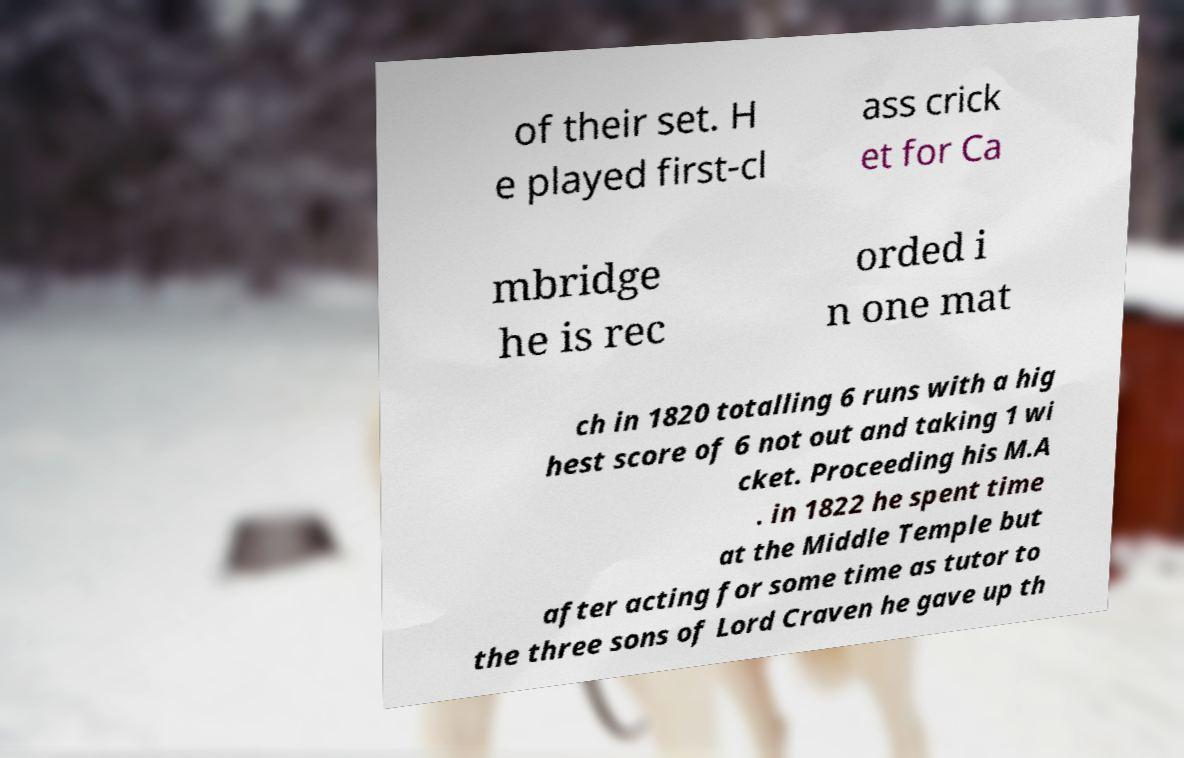Could you extract and type out the text from this image? of their set. H e played first-cl ass crick et for Ca mbridge he is rec orded i n one mat ch in 1820 totalling 6 runs with a hig hest score of 6 not out and taking 1 wi cket. Proceeding his M.A . in 1822 he spent time at the Middle Temple but after acting for some time as tutor to the three sons of Lord Craven he gave up th 